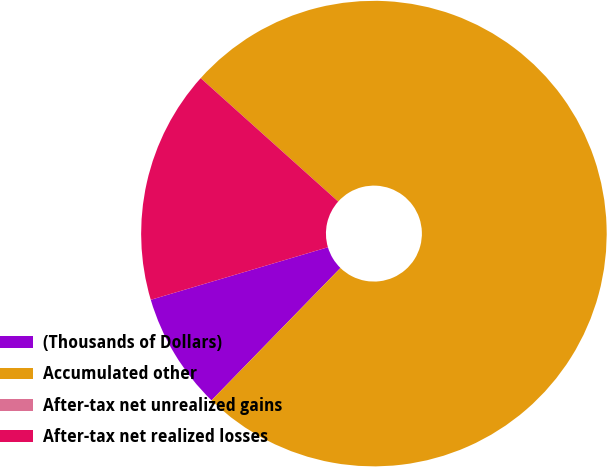Convert chart to OTSL. <chart><loc_0><loc_0><loc_500><loc_500><pie_chart><fcel>(Thousands of Dollars)<fcel>Accumulated other<fcel>After-tax net unrealized gains<fcel>After-tax net realized losses<nl><fcel>8.12%<fcel>75.65%<fcel>0.0%<fcel>16.23%<nl></chart> 